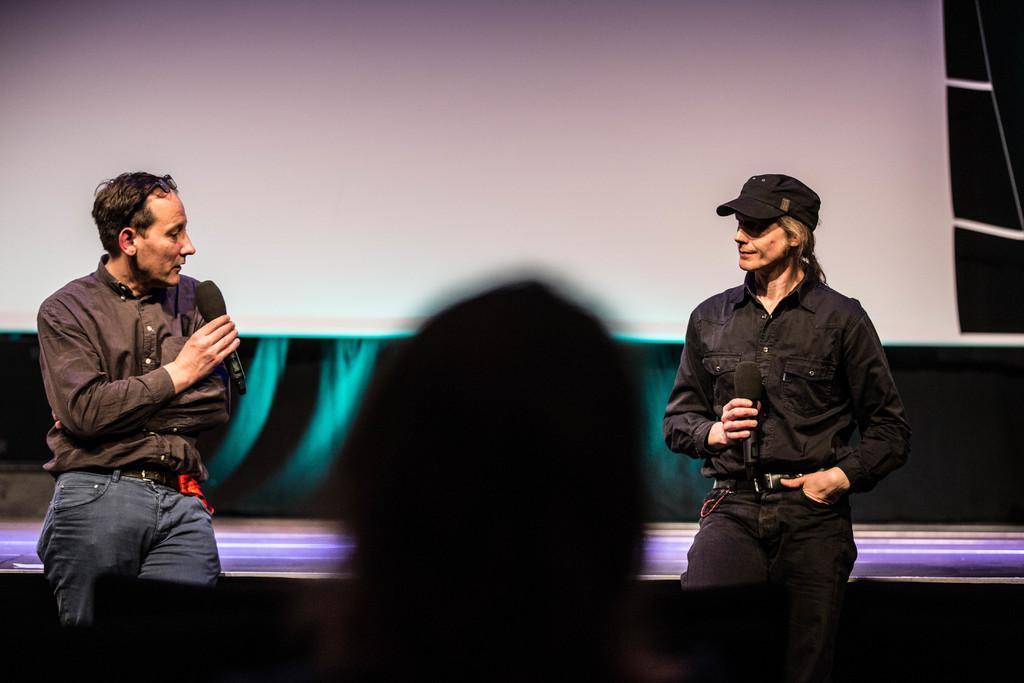Describe this image in one or two sentences. In this picture there are two men on the right and left side of the image. 